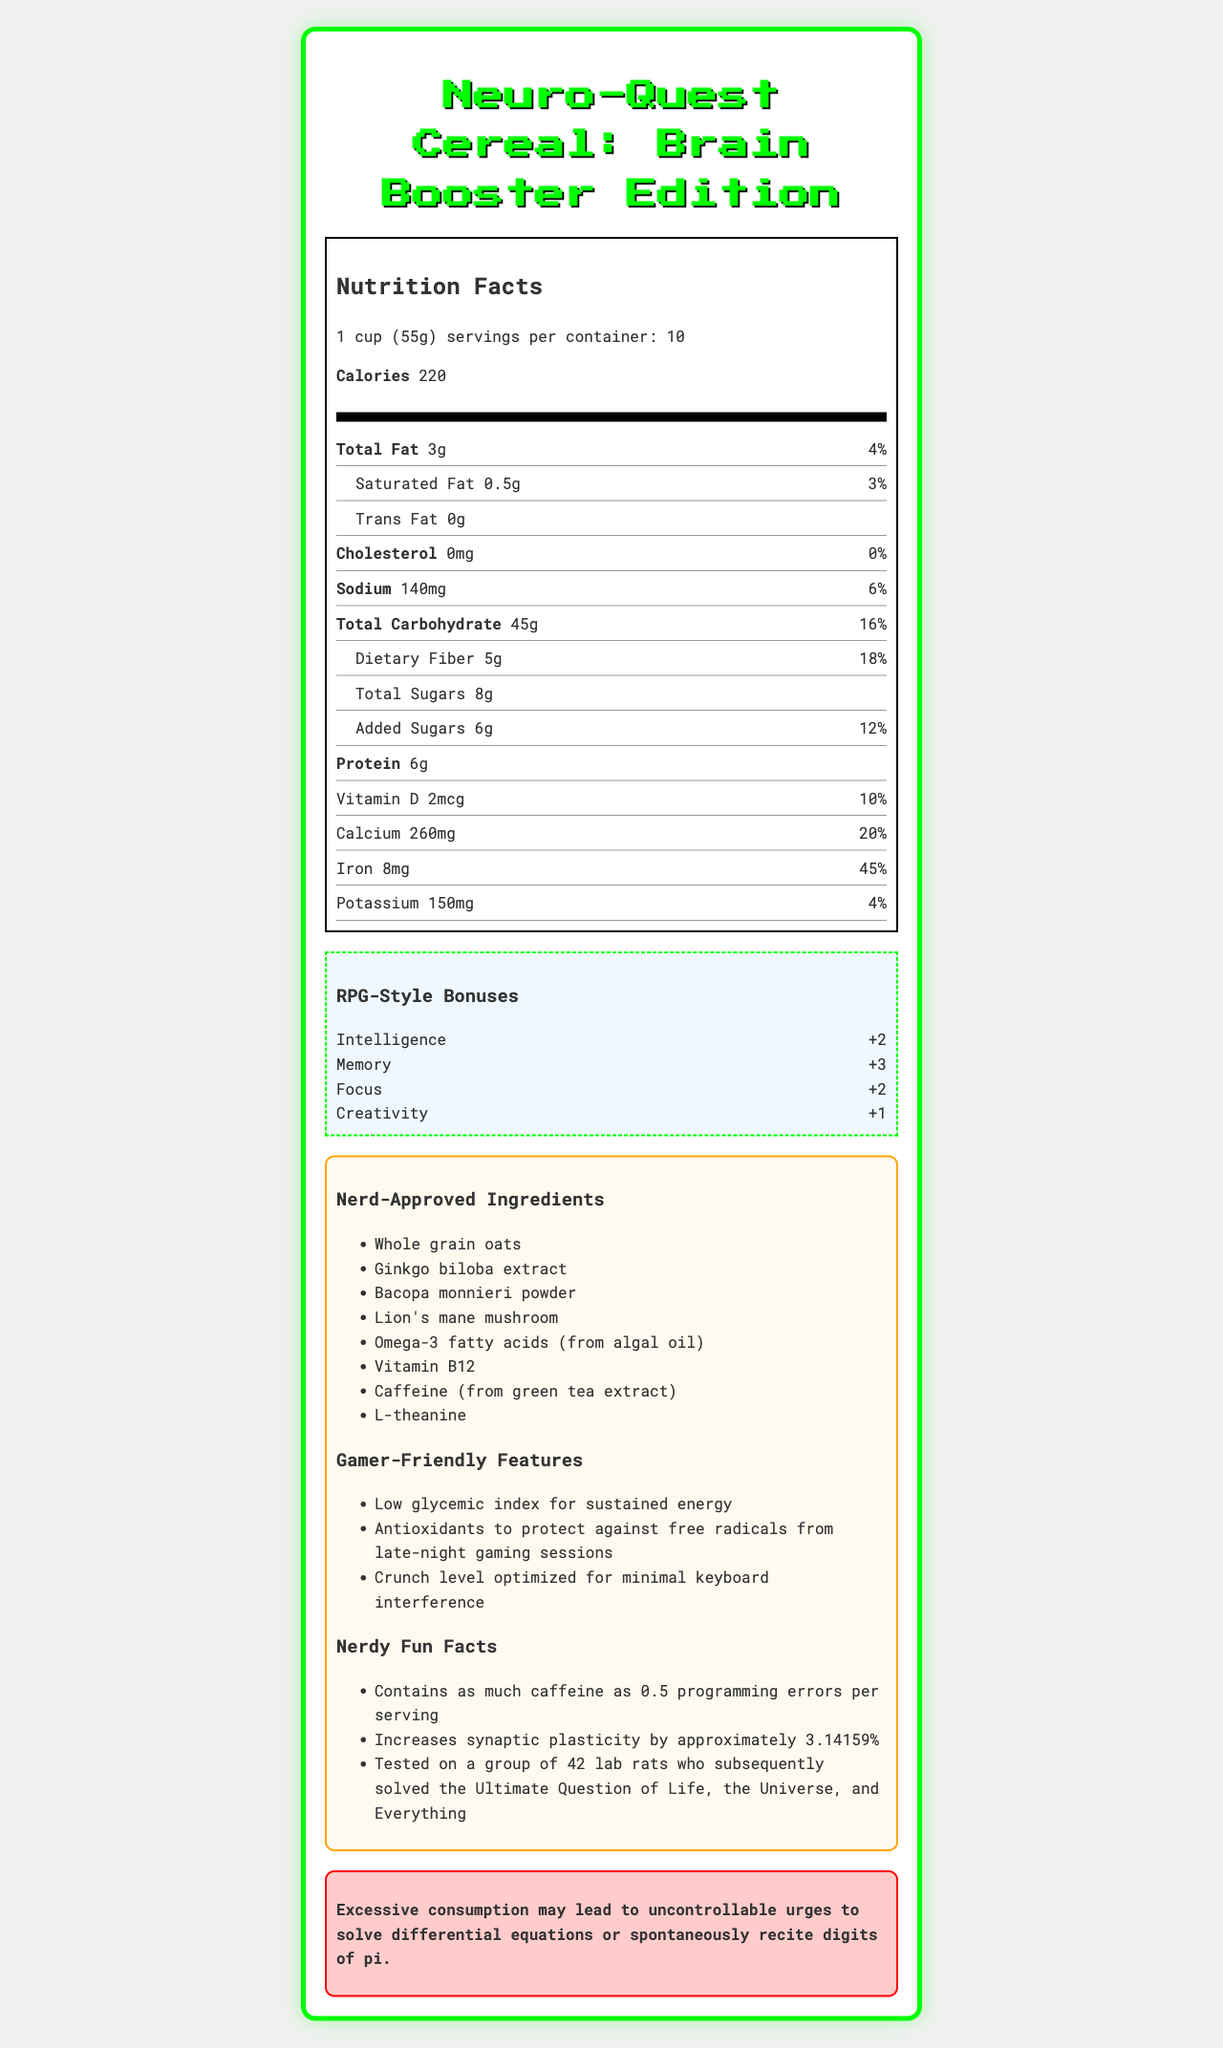How many servings are in each container of Neuro-Quest Cereal: Brain Booster Edition? According to the document, there are 10 servings per container.
Answer: 10 What is the amount of added sugars per serving? The nutrition facts list "Added Sugars" as 6g per serving.
Answer: 6g How much dietary fiber does one serving of Neuro-Quest Cereal contain? The document states that each serving contains 5g of dietary fiber.
Answer: 5g What percentage of the daily value of iron does one serving provide? The label specifies that one serving provides 45% of the daily value for iron.
Answer: 45% List two of the nerd-approved ingredients in the cereal. The list of nerd-approved ingredients includes Whole grain oats, Ginkgo biloba extract, Bacopa monnieri powder, Lion's mane mushroom, Omega-3 fatty acids (from algal oil), Vitamin B12, Caffeine (from green tea extract), and L-theanine.
Answer: Whole grain oats, Ginkgo biloba extract Which of the following is NOT a gamer-friendly feature mentioned for Neuro-Quest Cereal? A. Low glycemic index for sustained energy B. High protein content for muscle recovery C. Antioxidants to protect against free radicals from late-night gaming sessions D. Crunch level optimized for minimal keyboard interference The features listed are low glycemic index for sustained energy, antioxidants, and crunch level optimized for minimal keyboard interference. High protein content for muscle recovery is not mentioned.
Answer: B What are the RPG-style bonuses provided by the Brain Booster Edition of the cereal? A. Intelligence +3, Memory +2, Focus +4, Creativity +1 B. Intelligence +2, Memory +3, Focus +2, Creativity +1 C. Intelligence +2, Memory +2, Focus +3, Creativity +1 D. Intelligence +3, Memory +3, Focus +1, Creativity +2 The RPG-style bonuses listed are Intelligence +2, Memory +3, Focus +2, Creativity +1.
Answer: B Does the cereal contain any cholesterol? According to the nutrition facts, the cereal contains 0mg of cholesterol, which is 0% of the daily value.
Answer: No Summarize the main details provided in the Neuro-Quest Cereal: Brain Booster Edition document. The document provides detailed nutritional information, lists special ingredients, gaming advantages, fun trivia, and cautions, emphasizing the cereal's unique features and health benefits.
Answer: Neuro-Quest Cereal: Brain Booster Edition is a specialized cereal that provides various nutritional benefits and RPG-style intelligence boosts. It offers 220 calories per serving with 3g of total fat, 45g of total carbohydrates, 6g of protein, and various vitamins and minerals. It features nerd-approved ingredients like Whole grain oats, Ginkgo biloba extract, and Omega-3 fatty acids, as well as gamer-friendly attributes such as sustained energy and minimized crunch noise. The document also contains fun facts and a humorous warning. How much caffeine does one serving of the cereal contain? The document mentions that caffeine is one of the ingredients, but it does not specify the exact amount present in one serving.
Answer: Not enough information 